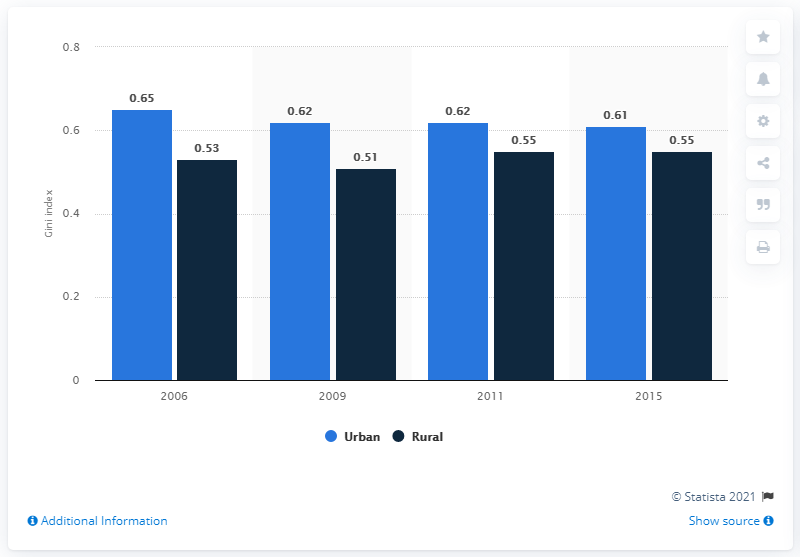Specify some key components in this picture. The highest urban coefficient in South Africa from 2006 to 2015 was 0.65. The difference between the shortest and tallest blue bars is 0.14. 